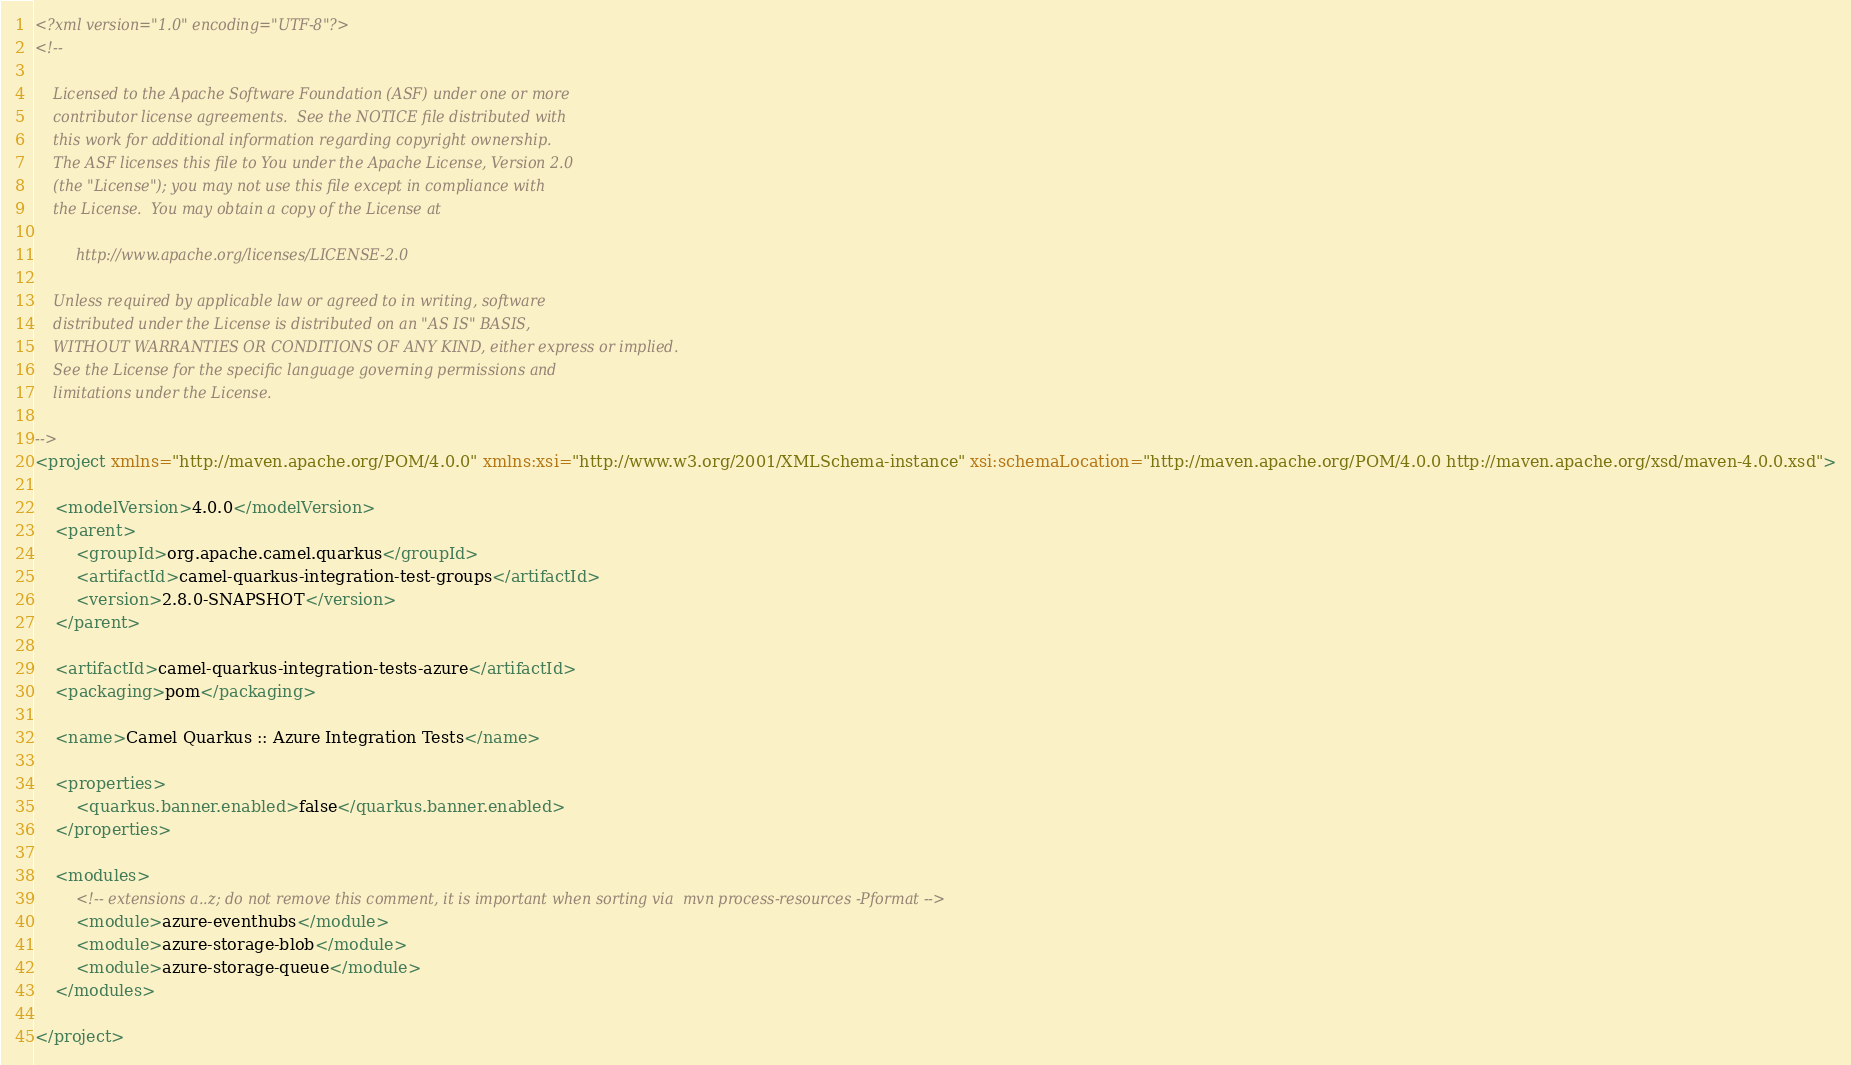<code> <loc_0><loc_0><loc_500><loc_500><_XML_><?xml version="1.0" encoding="UTF-8"?>
<!--

    Licensed to the Apache Software Foundation (ASF) under one or more
    contributor license agreements.  See the NOTICE file distributed with
    this work for additional information regarding copyright ownership.
    The ASF licenses this file to You under the Apache License, Version 2.0
    (the "License"); you may not use this file except in compliance with
    the License.  You may obtain a copy of the License at

         http://www.apache.org/licenses/LICENSE-2.0

    Unless required by applicable law or agreed to in writing, software
    distributed under the License is distributed on an "AS IS" BASIS,
    WITHOUT WARRANTIES OR CONDITIONS OF ANY KIND, either express or implied.
    See the License for the specific language governing permissions and
    limitations under the License.

-->
<project xmlns="http://maven.apache.org/POM/4.0.0" xmlns:xsi="http://www.w3.org/2001/XMLSchema-instance" xsi:schemaLocation="http://maven.apache.org/POM/4.0.0 http://maven.apache.org/xsd/maven-4.0.0.xsd">

    <modelVersion>4.0.0</modelVersion>
    <parent>
        <groupId>org.apache.camel.quarkus</groupId>
        <artifactId>camel-quarkus-integration-test-groups</artifactId>
        <version>2.8.0-SNAPSHOT</version>
    </parent>

    <artifactId>camel-quarkus-integration-tests-azure</artifactId>
    <packaging>pom</packaging>

    <name>Camel Quarkus :: Azure Integration Tests</name>

    <properties>
        <quarkus.banner.enabled>false</quarkus.banner.enabled>
    </properties>

    <modules>
        <!-- extensions a..z; do not remove this comment, it is important when sorting via  mvn process-resources -Pformat -->
        <module>azure-eventhubs</module>
        <module>azure-storage-blob</module>
        <module>azure-storage-queue</module>
    </modules>

</project>
</code> 